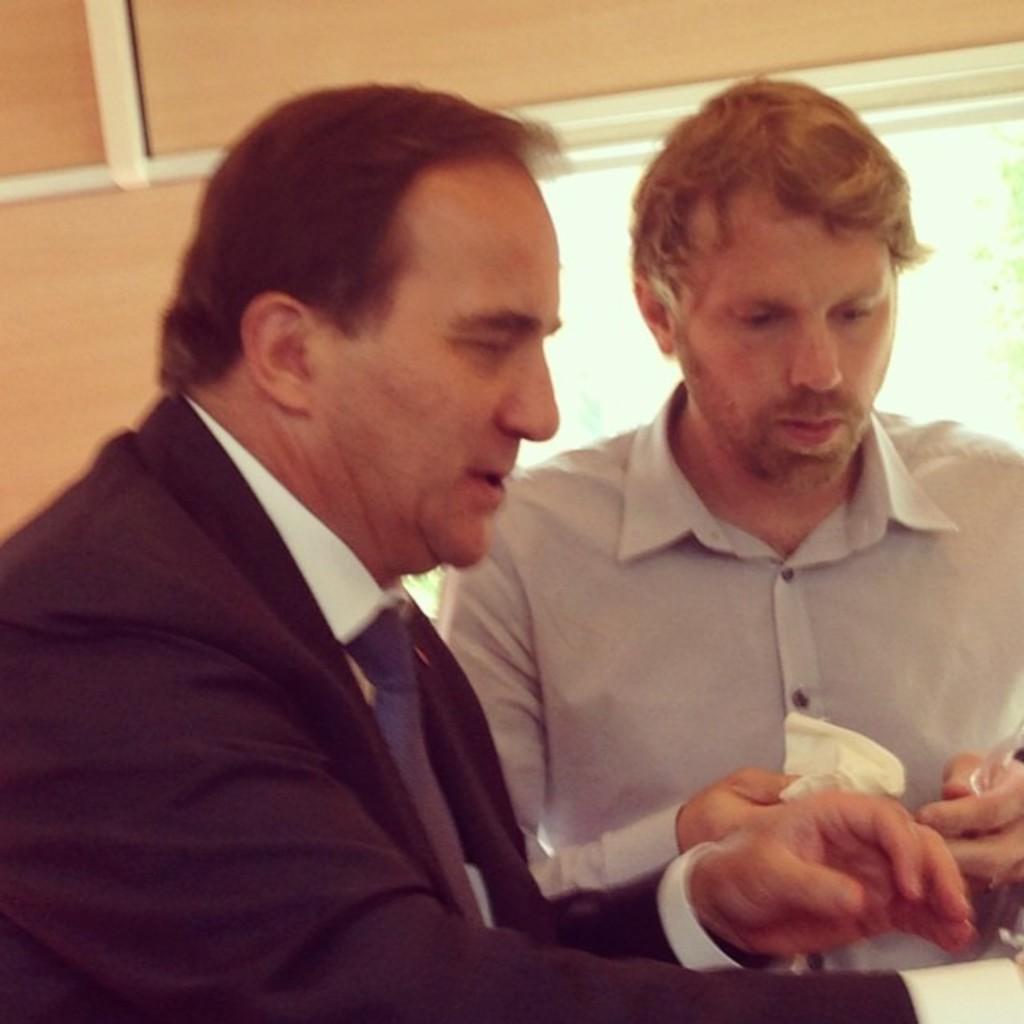Could you give a brief overview of what you see in this image? In the image there are two men, they are looking at something. In the background there is a window. 